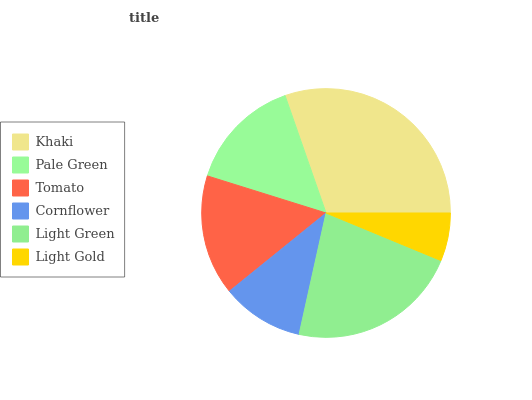Is Light Gold the minimum?
Answer yes or no. Yes. Is Khaki the maximum?
Answer yes or no. Yes. Is Pale Green the minimum?
Answer yes or no. No. Is Pale Green the maximum?
Answer yes or no. No. Is Khaki greater than Pale Green?
Answer yes or no. Yes. Is Pale Green less than Khaki?
Answer yes or no. Yes. Is Pale Green greater than Khaki?
Answer yes or no. No. Is Khaki less than Pale Green?
Answer yes or no. No. Is Tomato the high median?
Answer yes or no. Yes. Is Pale Green the low median?
Answer yes or no. Yes. Is Cornflower the high median?
Answer yes or no. No. Is Tomato the low median?
Answer yes or no. No. 